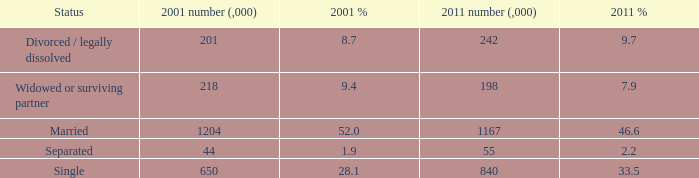What is the lowest 2011 number (,000)? 55.0. 